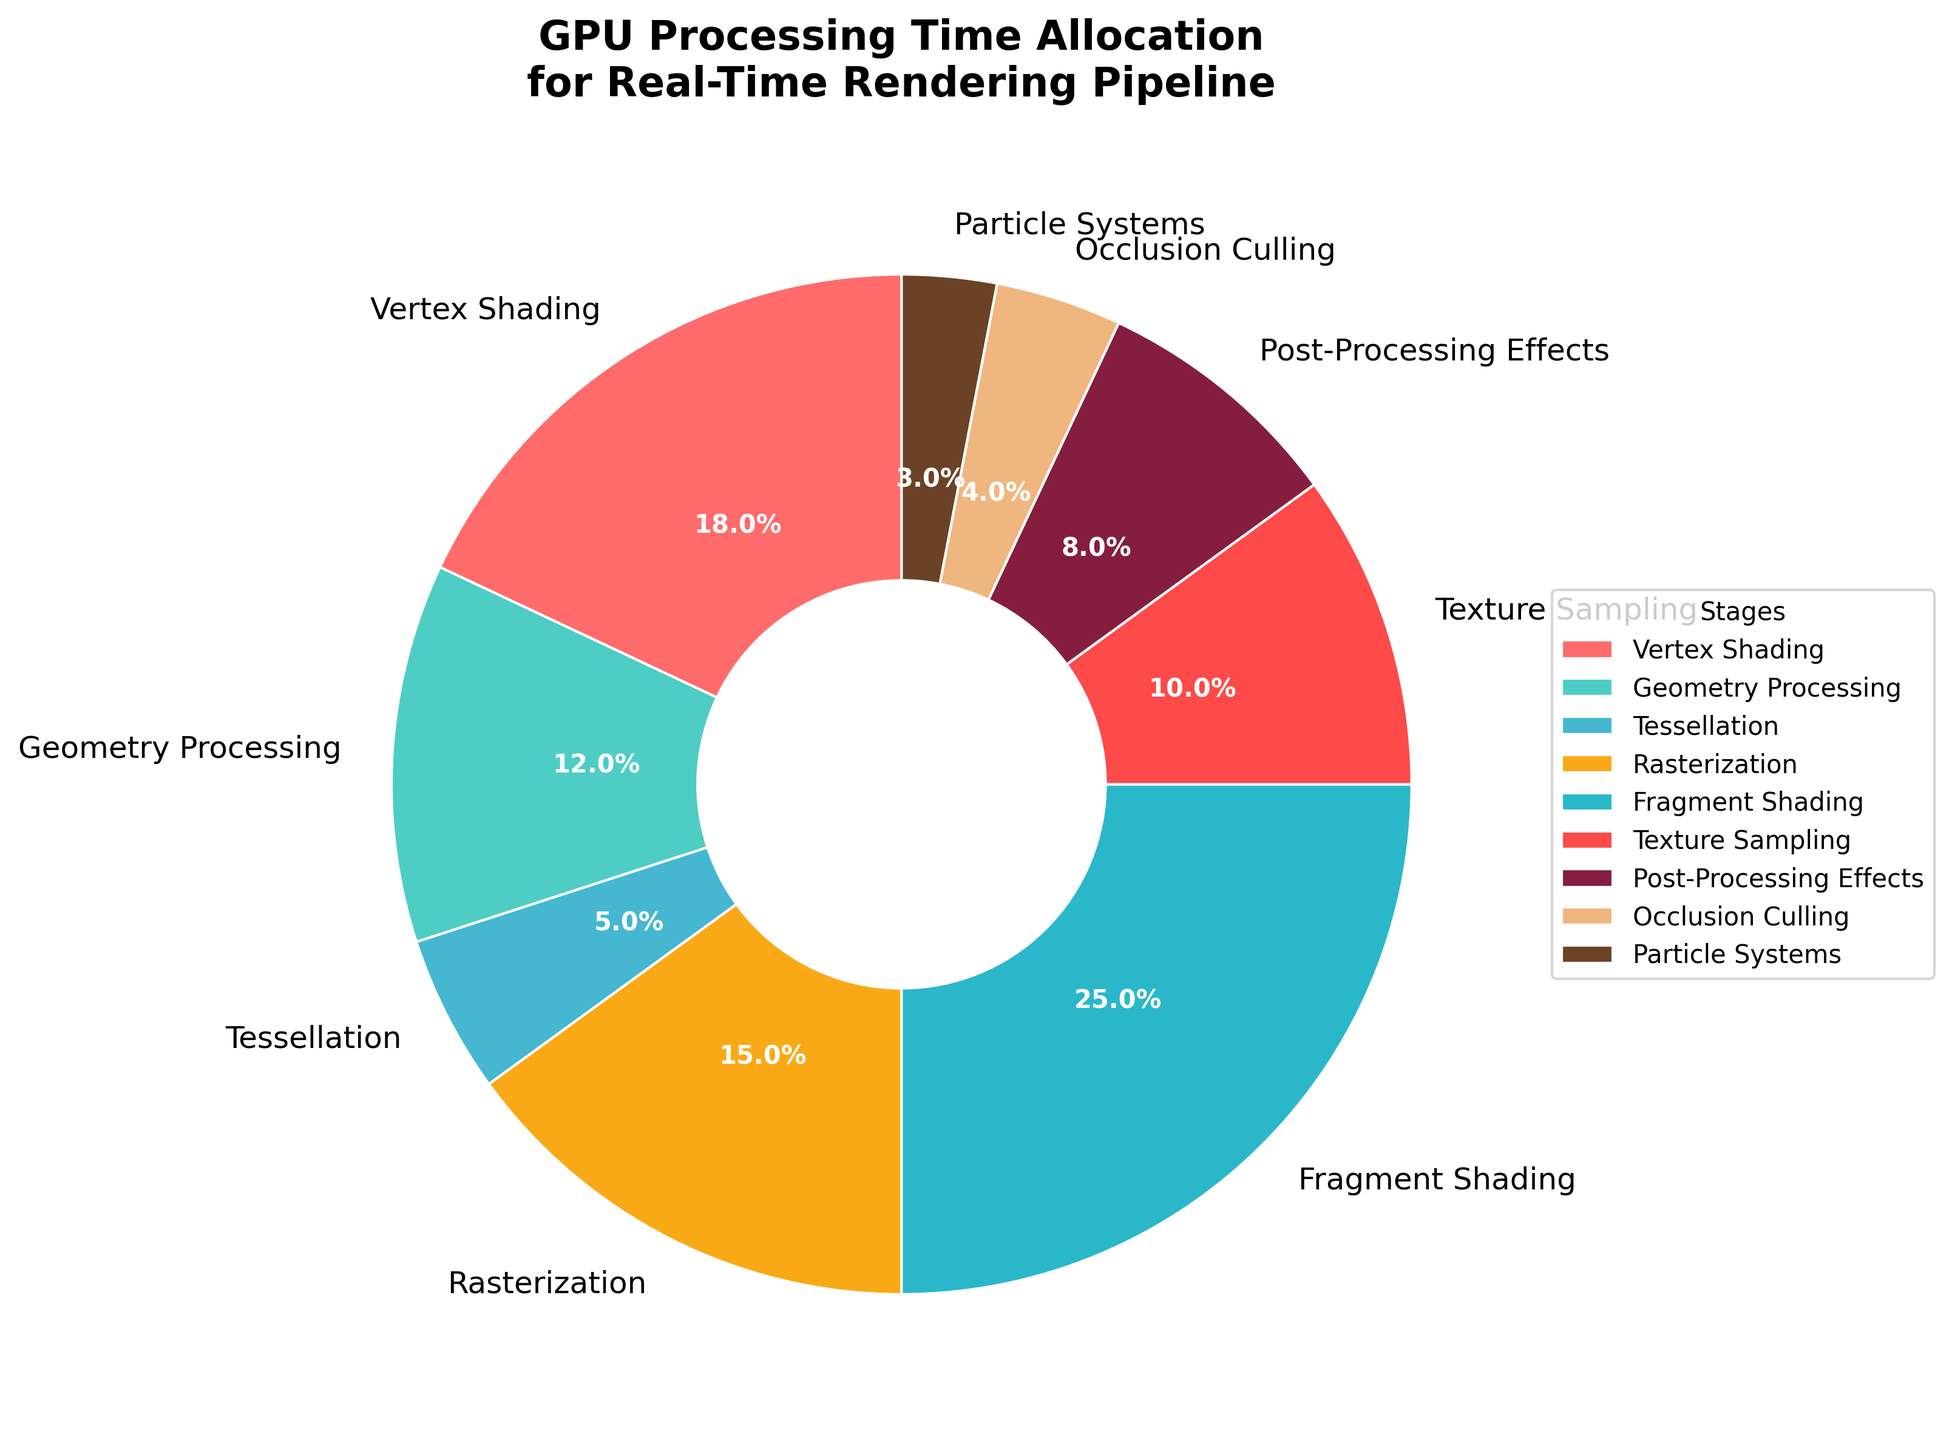What percentage of GPU processing time is allocated to Vertex Shading? Look at the section labeled "Vertex Shading" in the pie chart and note its percentage.
Answer: 18% Which stage uses more GPU processing time: Geometry Processing or Tessellation? Compare the percentages for "Geometry Processing" and "Tessellation" in the pie chart. Geometry Processing is 12% and Tessellation is 5%.
Answer: Geometry Processing What is the total percentage of GPU processing time allocated to Rasterization, Fragment Shading, and Texture Sampling? Add the percentages for "Rasterization" (15%), "Fragment Shading" (25%), and "Texture Sampling" (10%) as shown in the pie chart. 15 + 25 + 10 = 50
Answer: 50% Which stage has the lowest GPU processing time allocation, and what is the percentage? Identify the smallest percentage in the pie chart, which corresponds to the "Particle Systems" stage at 3%.
Answer: Particle Systems, 3% How much more GPU processing time is allocated to Fragment Shading compared to Vertex Shading? Compare the percentages of "Fragment Shading" (25%) and "Vertex Shading" (18%) and subtract to find the difference. 25 - 18 = 7
Answer: 7% Is the sum of GPU processing time allocated to Occlusion Culling and Post-Processing Effects greater than the GPU processing time allocated to Rasterization? Add the percentages of "Occlusion Culling" (4%) and "Post-Processing Effects" (8%) and compare the sum to "Rasterization" (15%). 4 + 8 = 12, which is less than 15.
Answer: No Are more GPU resources allocated to Geometry Processing than to Texture Sampling? Compare the percentages of "Geometry Processing" (12%) and "Texture Sampling" (10%) shown in the pie chart.
Answer: Yes What is the combined percentage of GPU processing time for stages with less than 10% allocation each? Add the percentages of "Tessellation" (5%), "Texture Sampling" (10%), "Post-Processing Effects" (8%), "Occlusion Culling" (4%), and "Particle Systems" (3%) as shown in the pie chart. 5 + 10 + 8 + 4 + 3 = 30
Answer: 30% What color is assigned to Occlusion Culling in the pie chart? Find the segment labeled "Occlusion Culling" and note its color.
Answer: Light tan 